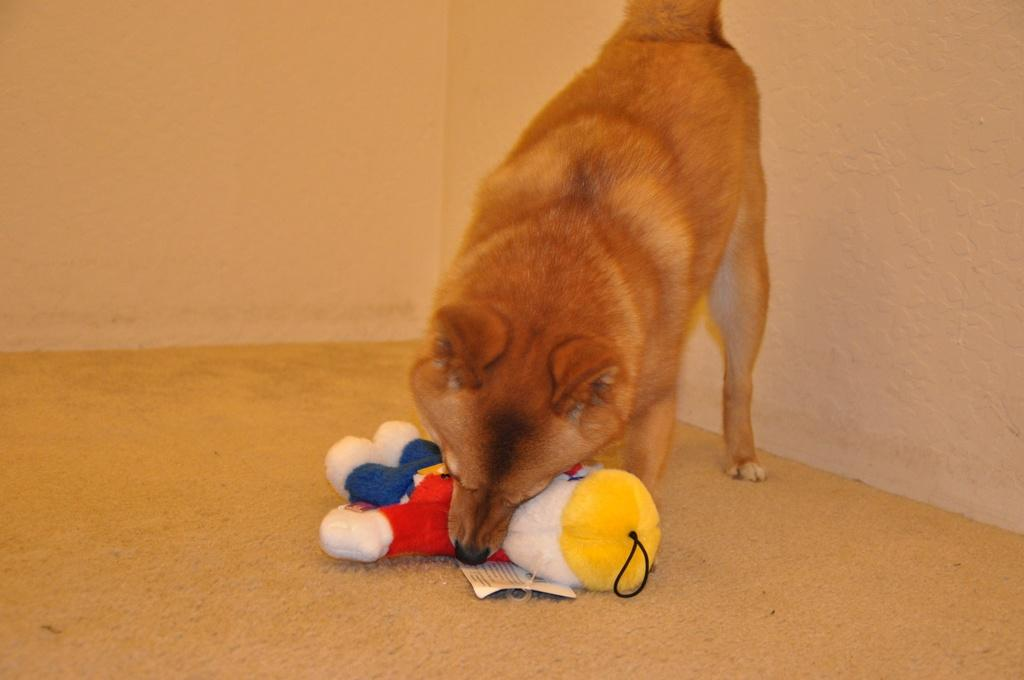What type of animal is present in the image? There is a dog in the image. What object can be seen on the floor in the image? There is a toy on the floor in the image. What can be seen in the background of the image? The background of the image includes walls. How many children are playing with the dog in the image? There are no children present in the image; it only features a dog and a toy on the floor. What type of berry can be seen growing on the walls in the image? There are no berries present in the image; the background only includes walls. 